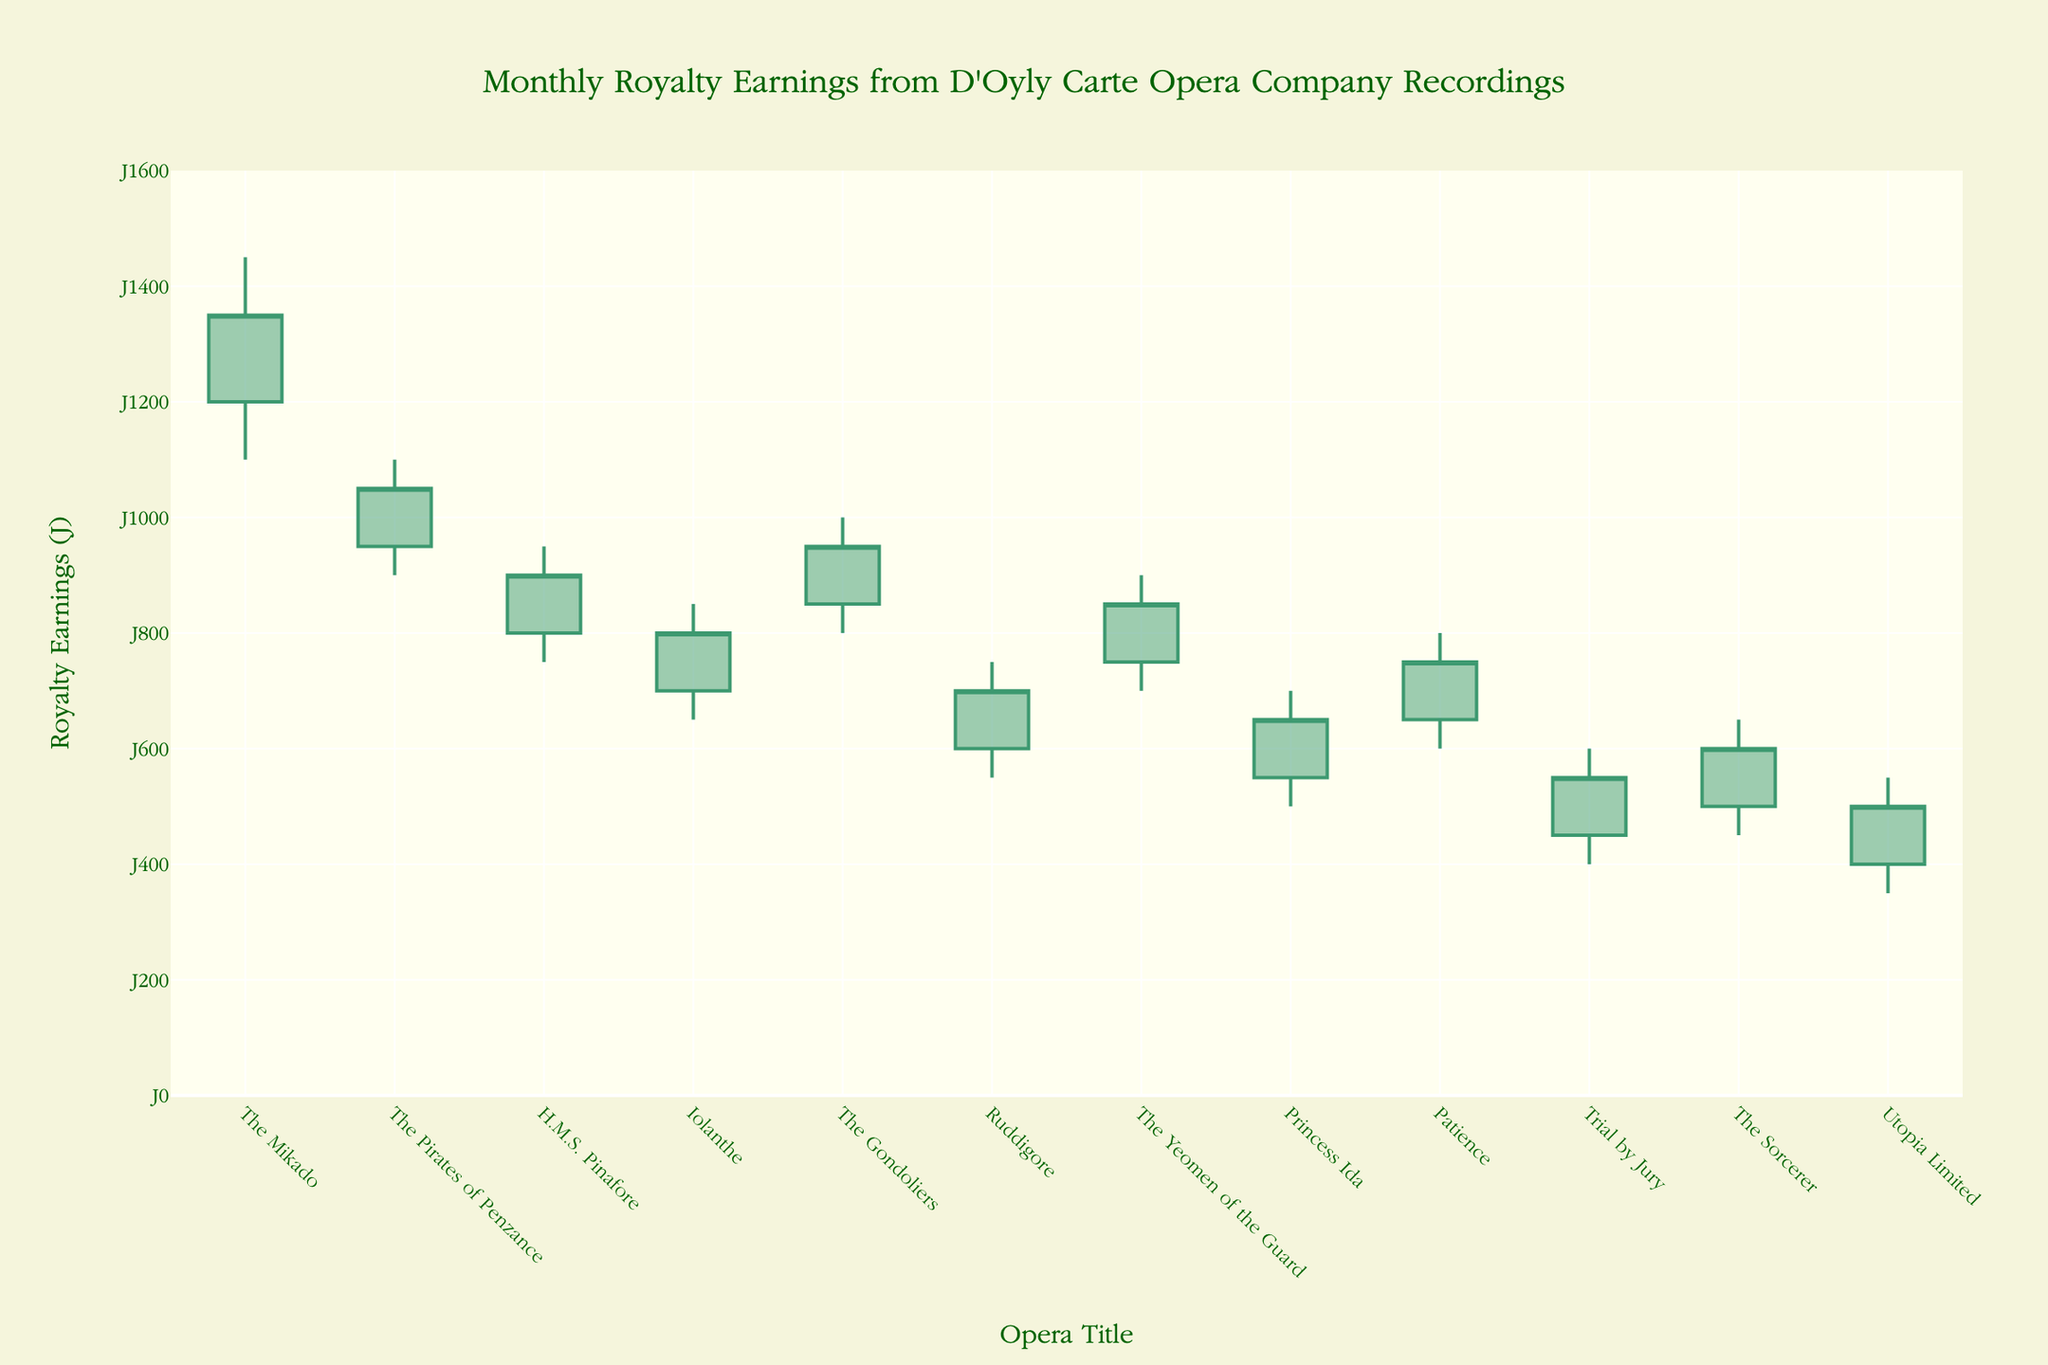What's the highest royalty earnings for 'The Mikado'? The highest royalty earnings for 'The Mikado' are represented by the highest value on the candlestick. Look at the "High" value for 'The Mikado' in the figure, which is £1450.
Answer: £1450 Which opera had the lowest closing royalty earnings in December? The opera's closing royalty earnings in December is represented by the "Close" value in the figure. For December, the relevant data point is 'Utopia Limited', and its Close value is £500.
Answer: Utopia Limited Compare 'The Pirates of Penzance' in February and 'Patience' in September: which had a higher opening royalty earnings? The opening royalty earnings for both 'The Pirates of Penzance' in February and 'Patience' in September can be compared by looking at their "Open" values. 'The Pirates of Penzance' had a higher opening at £950 versus 'Patience' at £650.
Answer: The Pirates of Penzance What was the average closing royalty earnings for 'H.M.S. Pinafore' in March and 'Iolanthe' in April? To find the average, add the closing values of 'H.M.S. Pinafore' (£900) and 'Iolanthe' (£800), then divide by 2. The calculation is (900 + 800) / 2 = 850.
Answer: £850 Which opera experienced the greatest range (difference between high and low) in royalty earnings? The range can be calculated by subtracting the lowest value from the highest value for each opera, and then comparing these ranges. 'The Mikado' has the highest range (1450 - 1100 = 350).
Answer: The Mikado Which opera had a higher closing value: 'Princess Ida' in August or 'Ruddigore' in June? To determine this, compare the "Close" values. 'Princess Ida' has a closing value of £650, whereas 'Ruddigore' closed at £700. Thus, 'Ruddigore' has a higher closing value.
Answer: Ruddigore Identify the opera with the lowest high value in the given dataset. By comparing the "High" values, 'Utopia Limited' had the lowest high value at £550.
Answer: Utopia Limited What notable visual difference can be identified between the earnings of 'The Mikado' and 'Trial by Jury'? 'The Mikado' shows a high value of £1450, quite taller than 'Trial by Jury' with its maximum high value at £600. This is a major visual difference, indicating higher earnings for 'The Mikado'.
Answer: 'The Mikado' has significantly higher earnings How much did the royalty earnings for 'The Mikado' increase from the open to the close in January? Look at the open and close values for 'The Mikado'. The increase is calculated as £1350 (close) - £1200 (open) = £150.
Answer: £150 Which opera’s earnings remained consistent, having their open and close values identical? Analyzing the candlesticks for each opera, all have different open and close values; none remained consistent.
Answer: None 